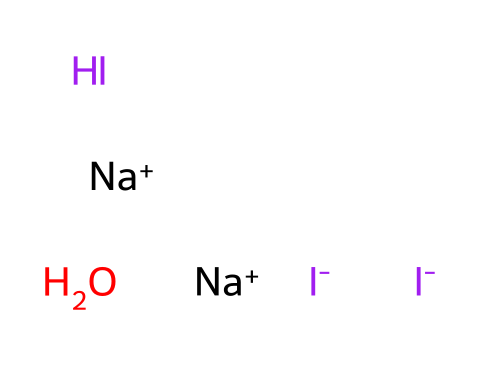What is the predominant halogen in this structure? The provided SMILES representation includes iodine atoms, indicated by the "I" symbols. While there is also a part of sodium and water, the focus is on the halogen. As there are three iodine atoms in the structure, iodine is the predominant halogen present.
Answer: iodine How many iodine atoms are in this iodine tincture? The SMILES representation shows three instances of the "I" symbol. Counting these, we can confirm that there are three iodine atoms in total.
Answer: three What is the charge of sodium in this compound? In the SMILES representation, "Na+" indicates that sodium has a positive charge, denoted by the "+" sign following "Na". Thus, sodium is positively charged.
Answer: positive What type of chemical reaction might this tincture be involved in? Iodine is known for its disinfectant properties; thus, it is likely to be involved in oxidation-reduction reactions where it can oxidize pathogens. This tendency is a common reaction for iodine-based compounds.
Answer: oxidation-reduction Which element in this mixture can act as a reducing agent? In the arrangement, the hydrogen atom, as represented in the structure, is accessible for bonding and can potentially donate electrons, which leads it to act as a reducing agent in some contexts.
Answer: hydrogen What role do iodine ions play in disinfectants? Iodine, represented as "I-", acts as an active disinfectant due to its high reactivity, particularly in killing bacteria and spores by disrupting their cellular functions.
Answer: disinfectant What is the molecular composition of the components present in this tincture? The entire SMILES representation reveals three iodine atoms, two sodium ions, and one water molecule (H2O). Together, this indicates the molecular composition consists of these elements in the specified ratio.
Answer: I3Na2H2O 